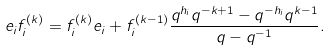Convert formula to latex. <formula><loc_0><loc_0><loc_500><loc_500>e _ { i } f _ { i } ^ { ( k ) } = f _ { i } ^ { ( k ) } e _ { i } + f _ { i } ^ { ( k - 1 ) } \frac { q ^ { h _ { i } } q ^ { - k + 1 } - q ^ { - h _ { i } } q ^ { k - 1 } } { q - q ^ { - 1 } } .</formula> 